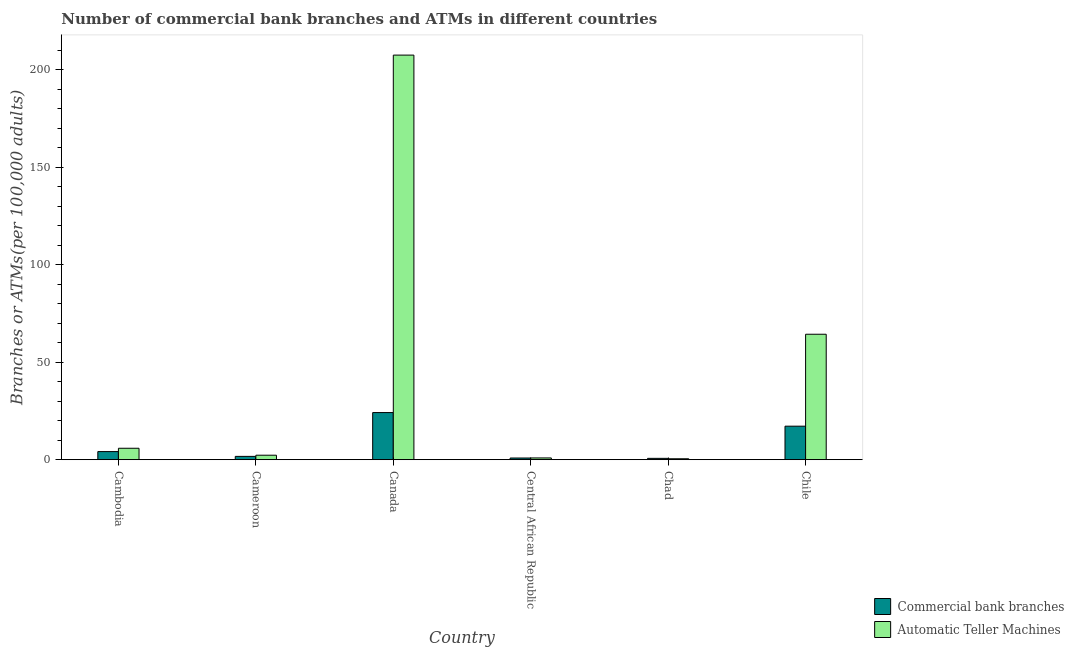How many groups of bars are there?
Give a very brief answer. 6. Are the number of bars per tick equal to the number of legend labels?
Give a very brief answer. Yes. Are the number of bars on each tick of the X-axis equal?
Make the answer very short. Yes. How many bars are there on the 3rd tick from the left?
Give a very brief answer. 2. What is the label of the 1st group of bars from the left?
Your answer should be compact. Cambodia. What is the number of atms in Cameroon?
Give a very brief answer. 2.3. Across all countries, what is the maximum number of atms?
Your answer should be compact. 207.56. Across all countries, what is the minimum number of commercal bank branches?
Make the answer very short. 0.69. In which country was the number of commercal bank branches maximum?
Your response must be concise. Canada. In which country was the number of commercal bank branches minimum?
Your answer should be very brief. Chad. What is the total number of atms in the graph?
Give a very brief answer. 281.49. What is the difference between the number of commercal bank branches in Cameroon and that in Chad?
Your response must be concise. 1.01. What is the difference between the number of commercal bank branches in Cambodia and the number of atms in Chad?
Give a very brief answer. 3.68. What is the average number of atms per country?
Offer a very short reply. 46.91. What is the difference between the number of atms and number of commercal bank branches in Central African Republic?
Provide a short and direct response. 0.04. What is the ratio of the number of commercal bank branches in Cameroon to that in Canada?
Give a very brief answer. 0.07. Is the number of commercal bank branches in Cambodia less than that in Central African Republic?
Ensure brevity in your answer.  No. Is the difference between the number of commercal bank branches in Chad and Chile greater than the difference between the number of atms in Chad and Chile?
Your answer should be compact. Yes. What is the difference between the highest and the second highest number of atms?
Ensure brevity in your answer.  143.2. What is the difference between the highest and the lowest number of atms?
Provide a short and direct response. 207.08. In how many countries, is the number of atms greater than the average number of atms taken over all countries?
Offer a terse response. 2. Is the sum of the number of commercal bank branches in Canada and Chad greater than the maximum number of atms across all countries?
Your answer should be very brief. No. What does the 2nd bar from the left in Central African Republic represents?
Offer a terse response. Automatic Teller Machines. What does the 1st bar from the right in Chile represents?
Your answer should be very brief. Automatic Teller Machines. How many bars are there?
Provide a succinct answer. 12. What is the difference between two consecutive major ticks on the Y-axis?
Offer a terse response. 50. Does the graph contain any zero values?
Your answer should be very brief. No. Does the graph contain grids?
Offer a terse response. No. What is the title of the graph?
Your answer should be very brief. Number of commercial bank branches and ATMs in different countries. Does "Time to import" appear as one of the legend labels in the graph?
Your answer should be very brief. No. What is the label or title of the Y-axis?
Offer a terse response. Branches or ATMs(per 100,0 adults). What is the Branches or ATMs(per 100,000 adults) of Commercial bank branches in Cambodia?
Ensure brevity in your answer.  4.16. What is the Branches or ATMs(per 100,000 adults) of Automatic Teller Machines in Cambodia?
Your answer should be very brief. 5.87. What is the Branches or ATMs(per 100,000 adults) of Commercial bank branches in Cameroon?
Make the answer very short. 1.7. What is the Branches or ATMs(per 100,000 adults) in Automatic Teller Machines in Cameroon?
Ensure brevity in your answer.  2.3. What is the Branches or ATMs(per 100,000 adults) in Commercial bank branches in Canada?
Your answer should be very brief. 24.18. What is the Branches or ATMs(per 100,000 adults) in Automatic Teller Machines in Canada?
Your response must be concise. 207.56. What is the Branches or ATMs(per 100,000 adults) of Commercial bank branches in Central African Republic?
Make the answer very short. 0.87. What is the Branches or ATMs(per 100,000 adults) of Automatic Teller Machines in Central African Republic?
Your response must be concise. 0.91. What is the Branches or ATMs(per 100,000 adults) of Commercial bank branches in Chad?
Give a very brief answer. 0.69. What is the Branches or ATMs(per 100,000 adults) in Automatic Teller Machines in Chad?
Your answer should be compact. 0.48. What is the Branches or ATMs(per 100,000 adults) of Commercial bank branches in Chile?
Keep it short and to the point. 17.19. What is the Branches or ATMs(per 100,000 adults) in Automatic Teller Machines in Chile?
Provide a short and direct response. 64.36. Across all countries, what is the maximum Branches or ATMs(per 100,000 adults) in Commercial bank branches?
Your response must be concise. 24.18. Across all countries, what is the maximum Branches or ATMs(per 100,000 adults) in Automatic Teller Machines?
Your answer should be very brief. 207.56. Across all countries, what is the minimum Branches or ATMs(per 100,000 adults) of Commercial bank branches?
Provide a short and direct response. 0.69. Across all countries, what is the minimum Branches or ATMs(per 100,000 adults) of Automatic Teller Machines?
Your response must be concise. 0.48. What is the total Branches or ATMs(per 100,000 adults) in Commercial bank branches in the graph?
Offer a terse response. 48.8. What is the total Branches or ATMs(per 100,000 adults) of Automatic Teller Machines in the graph?
Offer a very short reply. 281.49. What is the difference between the Branches or ATMs(per 100,000 adults) of Commercial bank branches in Cambodia and that in Cameroon?
Keep it short and to the point. 2.47. What is the difference between the Branches or ATMs(per 100,000 adults) in Automatic Teller Machines in Cambodia and that in Cameroon?
Your answer should be compact. 3.57. What is the difference between the Branches or ATMs(per 100,000 adults) of Commercial bank branches in Cambodia and that in Canada?
Provide a succinct answer. -20.01. What is the difference between the Branches or ATMs(per 100,000 adults) in Automatic Teller Machines in Cambodia and that in Canada?
Provide a short and direct response. -201.69. What is the difference between the Branches or ATMs(per 100,000 adults) in Commercial bank branches in Cambodia and that in Central African Republic?
Your answer should be very brief. 3.3. What is the difference between the Branches or ATMs(per 100,000 adults) in Automatic Teller Machines in Cambodia and that in Central African Republic?
Make the answer very short. 4.97. What is the difference between the Branches or ATMs(per 100,000 adults) in Commercial bank branches in Cambodia and that in Chad?
Ensure brevity in your answer.  3.47. What is the difference between the Branches or ATMs(per 100,000 adults) in Automatic Teller Machines in Cambodia and that in Chad?
Offer a terse response. 5.39. What is the difference between the Branches or ATMs(per 100,000 adults) of Commercial bank branches in Cambodia and that in Chile?
Offer a terse response. -13.03. What is the difference between the Branches or ATMs(per 100,000 adults) of Automatic Teller Machines in Cambodia and that in Chile?
Keep it short and to the point. -58.49. What is the difference between the Branches or ATMs(per 100,000 adults) of Commercial bank branches in Cameroon and that in Canada?
Make the answer very short. -22.48. What is the difference between the Branches or ATMs(per 100,000 adults) in Automatic Teller Machines in Cameroon and that in Canada?
Offer a terse response. -205.26. What is the difference between the Branches or ATMs(per 100,000 adults) of Commercial bank branches in Cameroon and that in Central African Republic?
Make the answer very short. 0.83. What is the difference between the Branches or ATMs(per 100,000 adults) in Automatic Teller Machines in Cameroon and that in Central African Republic?
Offer a very short reply. 1.39. What is the difference between the Branches or ATMs(per 100,000 adults) in Commercial bank branches in Cameroon and that in Chad?
Provide a succinct answer. 1.01. What is the difference between the Branches or ATMs(per 100,000 adults) of Automatic Teller Machines in Cameroon and that in Chad?
Ensure brevity in your answer.  1.81. What is the difference between the Branches or ATMs(per 100,000 adults) in Commercial bank branches in Cameroon and that in Chile?
Offer a terse response. -15.49. What is the difference between the Branches or ATMs(per 100,000 adults) of Automatic Teller Machines in Cameroon and that in Chile?
Your response must be concise. -62.06. What is the difference between the Branches or ATMs(per 100,000 adults) in Commercial bank branches in Canada and that in Central African Republic?
Provide a succinct answer. 23.31. What is the difference between the Branches or ATMs(per 100,000 adults) in Automatic Teller Machines in Canada and that in Central African Republic?
Give a very brief answer. 206.66. What is the difference between the Branches or ATMs(per 100,000 adults) in Commercial bank branches in Canada and that in Chad?
Make the answer very short. 23.48. What is the difference between the Branches or ATMs(per 100,000 adults) of Automatic Teller Machines in Canada and that in Chad?
Give a very brief answer. 207.08. What is the difference between the Branches or ATMs(per 100,000 adults) of Commercial bank branches in Canada and that in Chile?
Your response must be concise. 6.98. What is the difference between the Branches or ATMs(per 100,000 adults) of Automatic Teller Machines in Canada and that in Chile?
Offer a terse response. 143.2. What is the difference between the Branches or ATMs(per 100,000 adults) in Commercial bank branches in Central African Republic and that in Chad?
Ensure brevity in your answer.  0.18. What is the difference between the Branches or ATMs(per 100,000 adults) in Automatic Teller Machines in Central African Republic and that in Chad?
Your answer should be very brief. 0.42. What is the difference between the Branches or ATMs(per 100,000 adults) in Commercial bank branches in Central African Republic and that in Chile?
Provide a succinct answer. -16.32. What is the difference between the Branches or ATMs(per 100,000 adults) in Automatic Teller Machines in Central African Republic and that in Chile?
Your answer should be compact. -63.45. What is the difference between the Branches or ATMs(per 100,000 adults) in Commercial bank branches in Chad and that in Chile?
Provide a succinct answer. -16.5. What is the difference between the Branches or ATMs(per 100,000 adults) in Automatic Teller Machines in Chad and that in Chile?
Provide a short and direct response. -63.88. What is the difference between the Branches or ATMs(per 100,000 adults) in Commercial bank branches in Cambodia and the Branches or ATMs(per 100,000 adults) in Automatic Teller Machines in Cameroon?
Your answer should be compact. 1.87. What is the difference between the Branches or ATMs(per 100,000 adults) in Commercial bank branches in Cambodia and the Branches or ATMs(per 100,000 adults) in Automatic Teller Machines in Canada?
Your answer should be compact. -203.4. What is the difference between the Branches or ATMs(per 100,000 adults) in Commercial bank branches in Cambodia and the Branches or ATMs(per 100,000 adults) in Automatic Teller Machines in Central African Republic?
Your response must be concise. 3.26. What is the difference between the Branches or ATMs(per 100,000 adults) of Commercial bank branches in Cambodia and the Branches or ATMs(per 100,000 adults) of Automatic Teller Machines in Chad?
Your answer should be very brief. 3.68. What is the difference between the Branches or ATMs(per 100,000 adults) of Commercial bank branches in Cambodia and the Branches or ATMs(per 100,000 adults) of Automatic Teller Machines in Chile?
Provide a succinct answer. -60.2. What is the difference between the Branches or ATMs(per 100,000 adults) of Commercial bank branches in Cameroon and the Branches or ATMs(per 100,000 adults) of Automatic Teller Machines in Canada?
Provide a succinct answer. -205.86. What is the difference between the Branches or ATMs(per 100,000 adults) in Commercial bank branches in Cameroon and the Branches or ATMs(per 100,000 adults) in Automatic Teller Machines in Central African Republic?
Offer a very short reply. 0.79. What is the difference between the Branches or ATMs(per 100,000 adults) in Commercial bank branches in Cameroon and the Branches or ATMs(per 100,000 adults) in Automatic Teller Machines in Chad?
Ensure brevity in your answer.  1.22. What is the difference between the Branches or ATMs(per 100,000 adults) of Commercial bank branches in Cameroon and the Branches or ATMs(per 100,000 adults) of Automatic Teller Machines in Chile?
Provide a succinct answer. -62.66. What is the difference between the Branches or ATMs(per 100,000 adults) of Commercial bank branches in Canada and the Branches or ATMs(per 100,000 adults) of Automatic Teller Machines in Central African Republic?
Provide a succinct answer. 23.27. What is the difference between the Branches or ATMs(per 100,000 adults) in Commercial bank branches in Canada and the Branches or ATMs(per 100,000 adults) in Automatic Teller Machines in Chad?
Your response must be concise. 23.69. What is the difference between the Branches or ATMs(per 100,000 adults) in Commercial bank branches in Canada and the Branches or ATMs(per 100,000 adults) in Automatic Teller Machines in Chile?
Your answer should be compact. -40.18. What is the difference between the Branches or ATMs(per 100,000 adults) in Commercial bank branches in Central African Republic and the Branches or ATMs(per 100,000 adults) in Automatic Teller Machines in Chad?
Your answer should be very brief. 0.39. What is the difference between the Branches or ATMs(per 100,000 adults) of Commercial bank branches in Central African Republic and the Branches or ATMs(per 100,000 adults) of Automatic Teller Machines in Chile?
Provide a short and direct response. -63.49. What is the difference between the Branches or ATMs(per 100,000 adults) of Commercial bank branches in Chad and the Branches or ATMs(per 100,000 adults) of Automatic Teller Machines in Chile?
Provide a short and direct response. -63.67. What is the average Branches or ATMs(per 100,000 adults) in Commercial bank branches per country?
Your answer should be very brief. 8.13. What is the average Branches or ATMs(per 100,000 adults) of Automatic Teller Machines per country?
Provide a succinct answer. 46.91. What is the difference between the Branches or ATMs(per 100,000 adults) in Commercial bank branches and Branches or ATMs(per 100,000 adults) in Automatic Teller Machines in Cambodia?
Keep it short and to the point. -1.71. What is the difference between the Branches or ATMs(per 100,000 adults) of Commercial bank branches and Branches or ATMs(per 100,000 adults) of Automatic Teller Machines in Cameroon?
Provide a short and direct response. -0.6. What is the difference between the Branches or ATMs(per 100,000 adults) of Commercial bank branches and Branches or ATMs(per 100,000 adults) of Automatic Teller Machines in Canada?
Your answer should be very brief. -183.39. What is the difference between the Branches or ATMs(per 100,000 adults) of Commercial bank branches and Branches or ATMs(per 100,000 adults) of Automatic Teller Machines in Central African Republic?
Offer a terse response. -0.04. What is the difference between the Branches or ATMs(per 100,000 adults) in Commercial bank branches and Branches or ATMs(per 100,000 adults) in Automatic Teller Machines in Chad?
Keep it short and to the point. 0.21. What is the difference between the Branches or ATMs(per 100,000 adults) of Commercial bank branches and Branches or ATMs(per 100,000 adults) of Automatic Teller Machines in Chile?
Your answer should be very brief. -47.17. What is the ratio of the Branches or ATMs(per 100,000 adults) in Commercial bank branches in Cambodia to that in Cameroon?
Offer a very short reply. 2.45. What is the ratio of the Branches or ATMs(per 100,000 adults) of Automatic Teller Machines in Cambodia to that in Cameroon?
Keep it short and to the point. 2.55. What is the ratio of the Branches or ATMs(per 100,000 adults) of Commercial bank branches in Cambodia to that in Canada?
Keep it short and to the point. 0.17. What is the ratio of the Branches or ATMs(per 100,000 adults) in Automatic Teller Machines in Cambodia to that in Canada?
Provide a short and direct response. 0.03. What is the ratio of the Branches or ATMs(per 100,000 adults) of Commercial bank branches in Cambodia to that in Central African Republic?
Provide a succinct answer. 4.79. What is the ratio of the Branches or ATMs(per 100,000 adults) of Automatic Teller Machines in Cambodia to that in Central African Republic?
Keep it short and to the point. 6.47. What is the ratio of the Branches or ATMs(per 100,000 adults) in Commercial bank branches in Cambodia to that in Chad?
Offer a very short reply. 6. What is the ratio of the Branches or ATMs(per 100,000 adults) in Automatic Teller Machines in Cambodia to that in Chad?
Your answer should be very brief. 12.13. What is the ratio of the Branches or ATMs(per 100,000 adults) of Commercial bank branches in Cambodia to that in Chile?
Keep it short and to the point. 0.24. What is the ratio of the Branches or ATMs(per 100,000 adults) in Automatic Teller Machines in Cambodia to that in Chile?
Make the answer very short. 0.09. What is the ratio of the Branches or ATMs(per 100,000 adults) in Commercial bank branches in Cameroon to that in Canada?
Offer a terse response. 0.07. What is the ratio of the Branches or ATMs(per 100,000 adults) in Automatic Teller Machines in Cameroon to that in Canada?
Provide a succinct answer. 0.01. What is the ratio of the Branches or ATMs(per 100,000 adults) in Commercial bank branches in Cameroon to that in Central African Republic?
Give a very brief answer. 1.95. What is the ratio of the Branches or ATMs(per 100,000 adults) of Automatic Teller Machines in Cameroon to that in Central African Republic?
Give a very brief answer. 2.53. What is the ratio of the Branches or ATMs(per 100,000 adults) in Commercial bank branches in Cameroon to that in Chad?
Provide a short and direct response. 2.45. What is the ratio of the Branches or ATMs(per 100,000 adults) of Automatic Teller Machines in Cameroon to that in Chad?
Your response must be concise. 4.75. What is the ratio of the Branches or ATMs(per 100,000 adults) of Commercial bank branches in Cameroon to that in Chile?
Offer a terse response. 0.1. What is the ratio of the Branches or ATMs(per 100,000 adults) of Automatic Teller Machines in Cameroon to that in Chile?
Provide a short and direct response. 0.04. What is the ratio of the Branches or ATMs(per 100,000 adults) in Commercial bank branches in Canada to that in Central African Republic?
Offer a very short reply. 27.81. What is the ratio of the Branches or ATMs(per 100,000 adults) of Automatic Teller Machines in Canada to that in Central African Republic?
Provide a short and direct response. 228.82. What is the ratio of the Branches or ATMs(per 100,000 adults) in Commercial bank branches in Canada to that in Chad?
Provide a short and direct response. 34.85. What is the ratio of the Branches or ATMs(per 100,000 adults) in Automatic Teller Machines in Canada to that in Chad?
Make the answer very short. 428.86. What is the ratio of the Branches or ATMs(per 100,000 adults) in Commercial bank branches in Canada to that in Chile?
Provide a succinct answer. 1.41. What is the ratio of the Branches or ATMs(per 100,000 adults) of Automatic Teller Machines in Canada to that in Chile?
Provide a short and direct response. 3.23. What is the ratio of the Branches or ATMs(per 100,000 adults) in Commercial bank branches in Central African Republic to that in Chad?
Give a very brief answer. 1.25. What is the ratio of the Branches or ATMs(per 100,000 adults) in Automatic Teller Machines in Central African Republic to that in Chad?
Offer a terse response. 1.87. What is the ratio of the Branches or ATMs(per 100,000 adults) in Commercial bank branches in Central African Republic to that in Chile?
Give a very brief answer. 0.05. What is the ratio of the Branches or ATMs(per 100,000 adults) of Automatic Teller Machines in Central African Republic to that in Chile?
Offer a terse response. 0.01. What is the ratio of the Branches or ATMs(per 100,000 adults) of Commercial bank branches in Chad to that in Chile?
Provide a short and direct response. 0.04. What is the ratio of the Branches or ATMs(per 100,000 adults) of Automatic Teller Machines in Chad to that in Chile?
Give a very brief answer. 0.01. What is the difference between the highest and the second highest Branches or ATMs(per 100,000 adults) of Commercial bank branches?
Offer a very short reply. 6.98. What is the difference between the highest and the second highest Branches or ATMs(per 100,000 adults) of Automatic Teller Machines?
Offer a terse response. 143.2. What is the difference between the highest and the lowest Branches or ATMs(per 100,000 adults) of Commercial bank branches?
Offer a terse response. 23.48. What is the difference between the highest and the lowest Branches or ATMs(per 100,000 adults) in Automatic Teller Machines?
Your response must be concise. 207.08. 